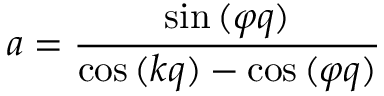Convert formula to latex. <formula><loc_0><loc_0><loc_500><loc_500>a = \frac { \sin { ( \varphi q ) } } { \cos { ( k q ) } - \cos { ( \varphi q ) } }</formula> 